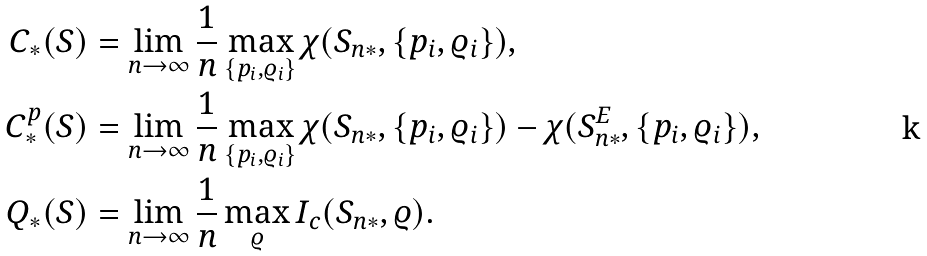<formula> <loc_0><loc_0><loc_500><loc_500>C _ { * } ( S ) & = \lim _ { n \to \infty } \frac { 1 } { n } \max _ { \{ p _ { i } , \varrho _ { i } \} } \chi ( S _ { n * } , \{ p _ { i } , \varrho _ { i } \} ) , \\ C _ { * } ^ { p } ( S ) & = \lim _ { n \to \infty } \frac { 1 } { n } \max _ { \{ p _ { i } , \varrho _ { i } \} } \chi ( S _ { n * } , \{ p _ { i } , \varrho _ { i } \} ) - \chi ( S _ { n * } ^ { E } , \{ p _ { i } , \varrho _ { i } \} ) , \\ Q _ { * } ( S ) & = \lim _ { n \to \infty } \frac { 1 } { n } \max _ { \varrho } I _ { c } ( S _ { n * } , \varrho ) .</formula> 